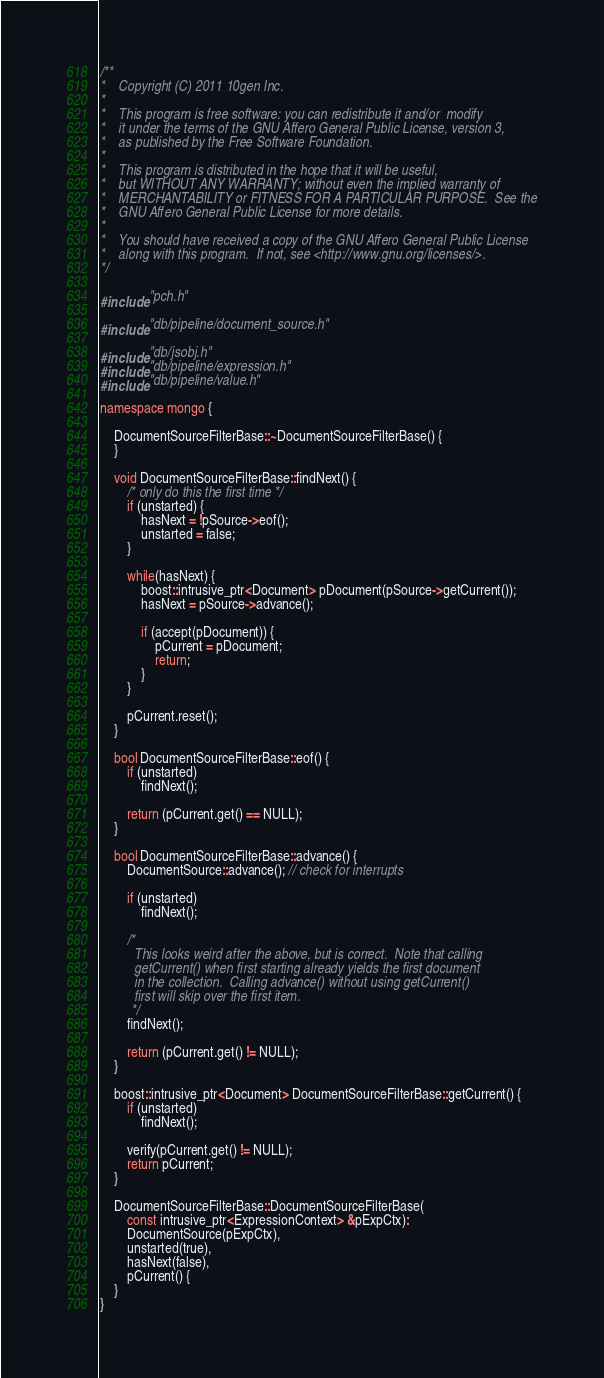Convert code to text. <code><loc_0><loc_0><loc_500><loc_500><_C++_>/**
*    Copyright (C) 2011 10gen Inc.
*
*    This program is free software: you can redistribute it and/or  modify
*    it under the terms of the GNU Affero General Public License, version 3,
*    as published by the Free Software Foundation.
*
*    This program is distributed in the hope that it will be useful,
*    but WITHOUT ANY WARRANTY; without even the implied warranty of
*    MERCHANTABILITY or FITNESS FOR A PARTICULAR PURPOSE.  See the
*    GNU Affero General Public License for more details.
*
*    You should have received a copy of the GNU Affero General Public License
*    along with this program.  If not, see <http://www.gnu.org/licenses/>.
*/

#include "pch.h"

#include "db/pipeline/document_source.h"

#include "db/jsobj.h"
#include "db/pipeline/expression.h"
#include "db/pipeline/value.h"

namespace mongo {

    DocumentSourceFilterBase::~DocumentSourceFilterBase() {
    }

    void DocumentSourceFilterBase::findNext() {
        /* only do this the first time */
        if (unstarted) {
            hasNext = !pSource->eof();
            unstarted = false;
        }

        while(hasNext) {
            boost::intrusive_ptr<Document> pDocument(pSource->getCurrent());
            hasNext = pSource->advance();

            if (accept(pDocument)) {
                pCurrent = pDocument;
                return;
            }
        }

        pCurrent.reset();
    }

    bool DocumentSourceFilterBase::eof() {
        if (unstarted)
            findNext();

        return (pCurrent.get() == NULL);
    }

    bool DocumentSourceFilterBase::advance() {
        DocumentSource::advance(); // check for interrupts

        if (unstarted)
            findNext();

        /*
          This looks weird after the above, but is correct.  Note that calling
          getCurrent() when first starting already yields the first document
          in the collection.  Calling advance() without using getCurrent()
          first will skip over the first item.
         */
        findNext();

        return (pCurrent.get() != NULL);
    }

    boost::intrusive_ptr<Document> DocumentSourceFilterBase::getCurrent() {
        if (unstarted)
            findNext();

        verify(pCurrent.get() != NULL);
        return pCurrent;
    }

    DocumentSourceFilterBase::DocumentSourceFilterBase(
        const intrusive_ptr<ExpressionContext> &pExpCtx):
        DocumentSource(pExpCtx),
        unstarted(true),
        hasNext(false),
        pCurrent() {
    }
}
</code> 